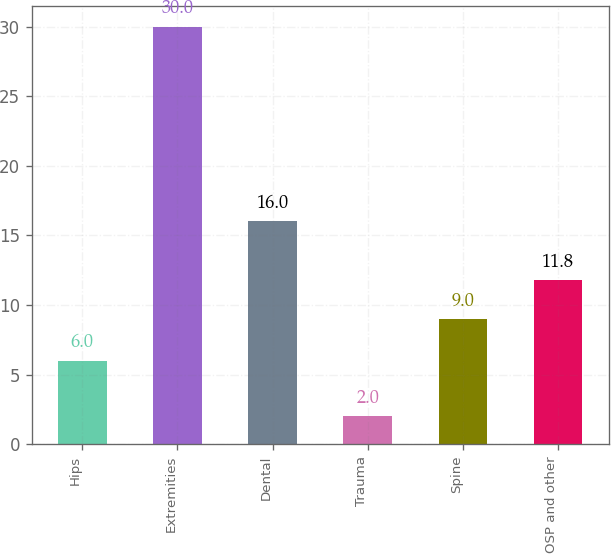Convert chart to OTSL. <chart><loc_0><loc_0><loc_500><loc_500><bar_chart><fcel>Hips<fcel>Extremities<fcel>Dental<fcel>Trauma<fcel>Spine<fcel>OSP and other<nl><fcel>6<fcel>30<fcel>16<fcel>2<fcel>9<fcel>11.8<nl></chart> 